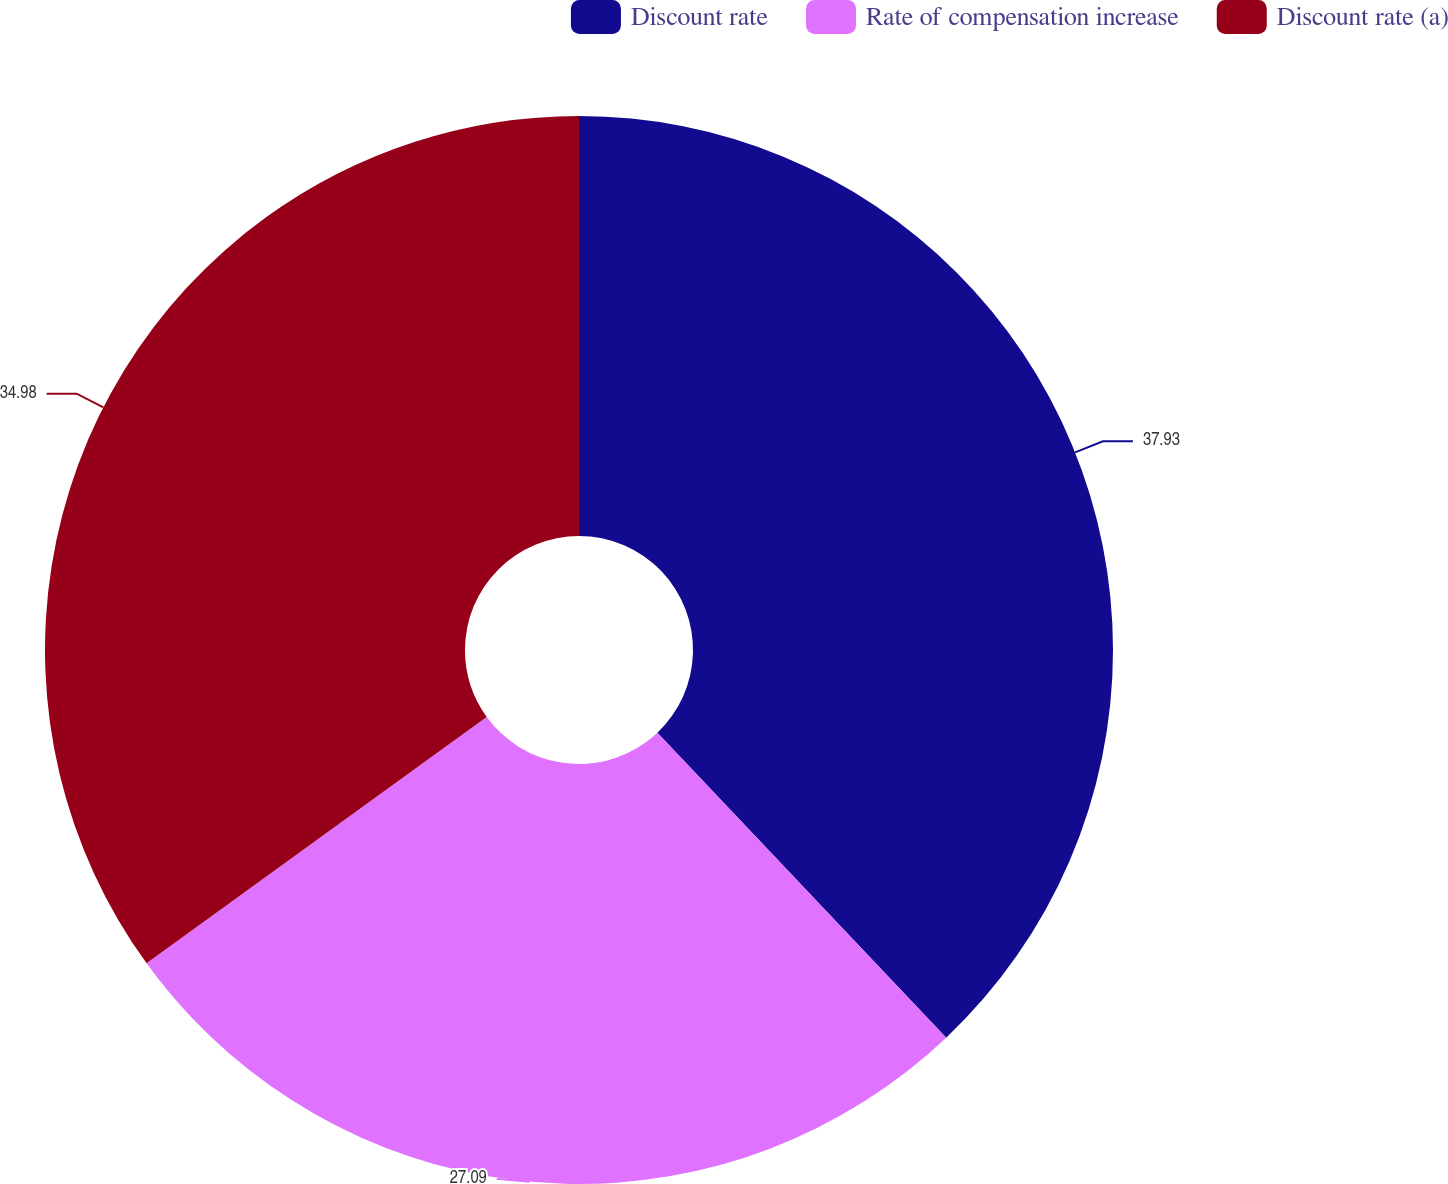<chart> <loc_0><loc_0><loc_500><loc_500><pie_chart><fcel>Discount rate<fcel>Rate of compensation increase<fcel>Discount rate (a)<nl><fcel>37.93%<fcel>27.09%<fcel>34.98%<nl></chart> 